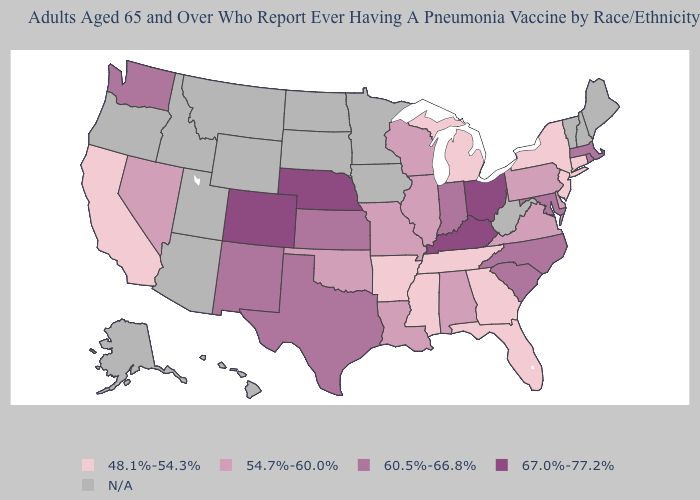Does Virginia have the lowest value in the USA?
Concise answer only. No. Does Kentucky have the highest value in the USA?
Give a very brief answer. Yes. What is the value of California?
Concise answer only. 48.1%-54.3%. What is the highest value in states that border Massachusetts?
Be succinct. 60.5%-66.8%. Does Colorado have the highest value in the West?
Quick response, please. Yes. Is the legend a continuous bar?
Answer briefly. No. What is the value of Arkansas?
Quick response, please. 48.1%-54.3%. What is the value of South Dakota?
Keep it brief. N/A. What is the lowest value in the MidWest?
Be succinct. 48.1%-54.3%. What is the value of Arkansas?
Be succinct. 48.1%-54.3%. What is the value of Maine?
Concise answer only. N/A. What is the value of Missouri?
Answer briefly. 54.7%-60.0%. Name the states that have a value in the range 54.7%-60.0%?
Answer briefly. Alabama, Delaware, Illinois, Louisiana, Missouri, Nevada, Oklahoma, Pennsylvania, Virginia, Wisconsin. Does Indiana have the lowest value in the MidWest?
Short answer required. No. Does Michigan have the lowest value in the USA?
Quick response, please. Yes. 